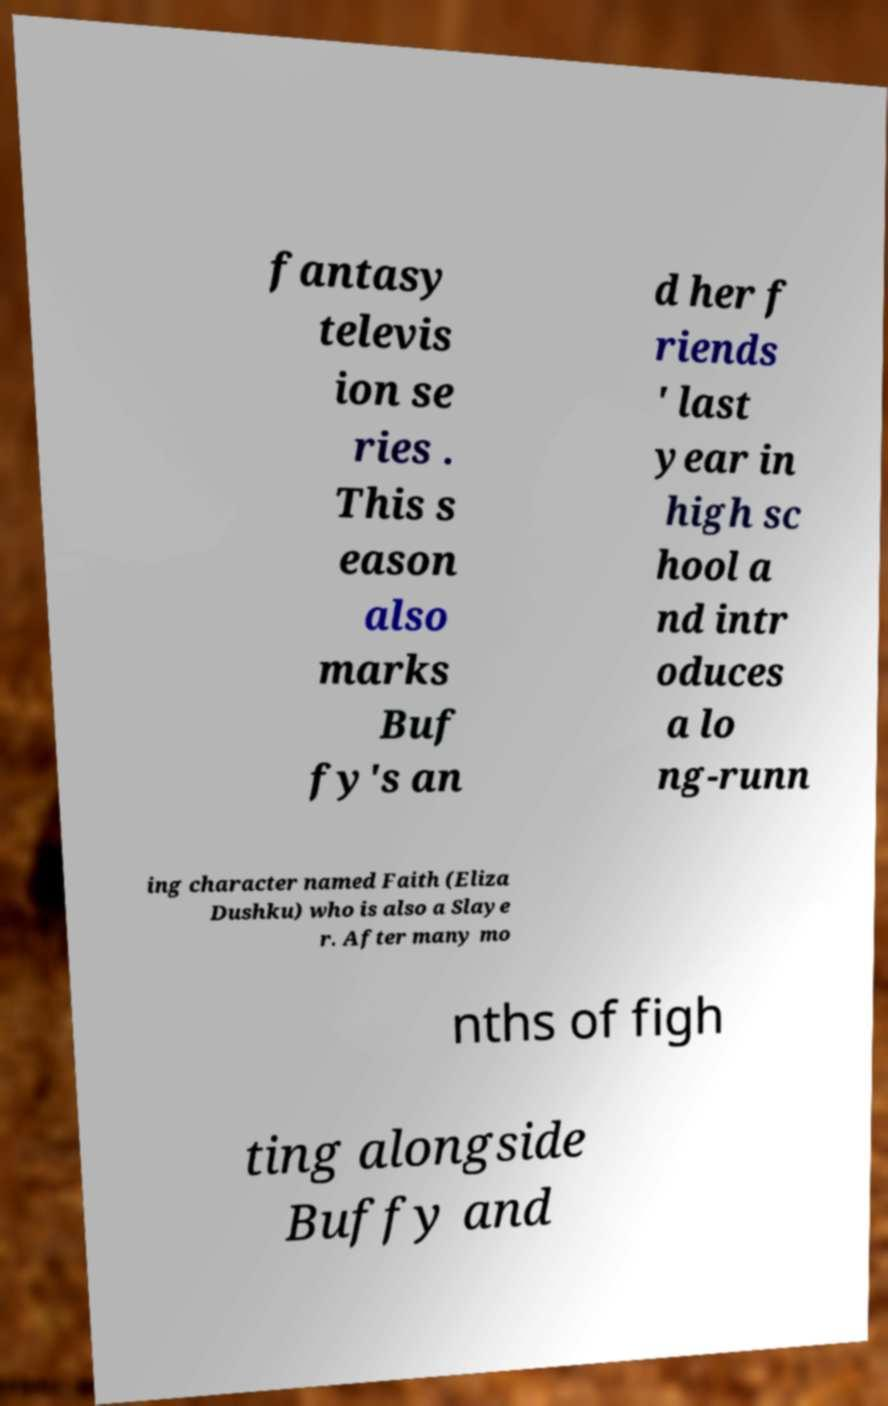Can you read and provide the text displayed in the image?This photo seems to have some interesting text. Can you extract and type it out for me? fantasy televis ion se ries . This s eason also marks Buf fy's an d her f riends ' last year in high sc hool a nd intr oduces a lo ng-runn ing character named Faith (Eliza Dushku) who is also a Slaye r. After many mo nths of figh ting alongside Buffy and 